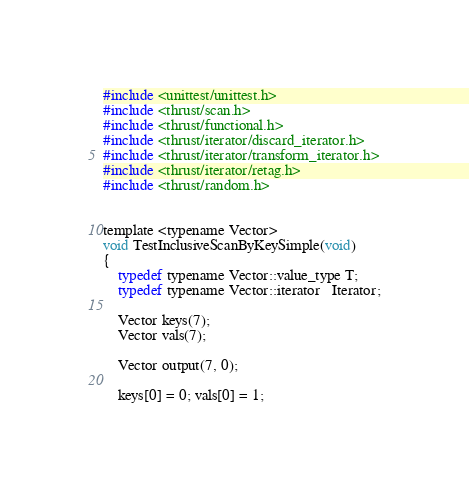Convert code to text. <code><loc_0><loc_0><loc_500><loc_500><_Cuda_>#include <unittest/unittest.h>
#include <thrust/scan.h>
#include <thrust/functional.h>
#include <thrust/iterator/discard_iterator.h>
#include <thrust/iterator/transform_iterator.h>
#include <thrust/iterator/retag.h>
#include <thrust/random.h>


template <typename Vector>
void TestInclusiveScanByKeySimple(void)
{
    typedef typename Vector::value_type T;
    typedef typename Vector::iterator   Iterator;

    Vector keys(7);
    Vector vals(7);

    Vector output(7, 0);

    keys[0] = 0; vals[0] = 1;</code> 